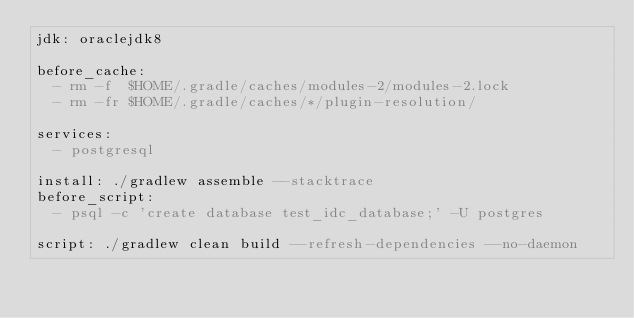<code> <loc_0><loc_0><loc_500><loc_500><_YAML_>jdk: oraclejdk8

before_cache:
  - rm -f  $HOME/.gradle/caches/modules-2/modules-2.lock
  - rm -fr $HOME/.gradle/caches/*/plugin-resolution/

services:
  - postgresql

install: ./gradlew assemble --stacktrace
before_script:
  - psql -c 'create database test_idc_database;' -U postgres

script: ./gradlew clean build --refresh-dependencies --no-daemon</code> 